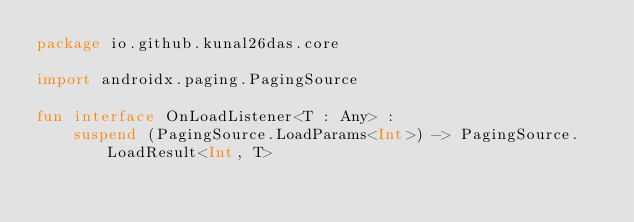Convert code to text. <code><loc_0><loc_0><loc_500><loc_500><_Kotlin_>package io.github.kunal26das.core

import androidx.paging.PagingSource

fun interface OnLoadListener<T : Any> :
    suspend (PagingSource.LoadParams<Int>) -> PagingSource.LoadResult<Int, T></code> 